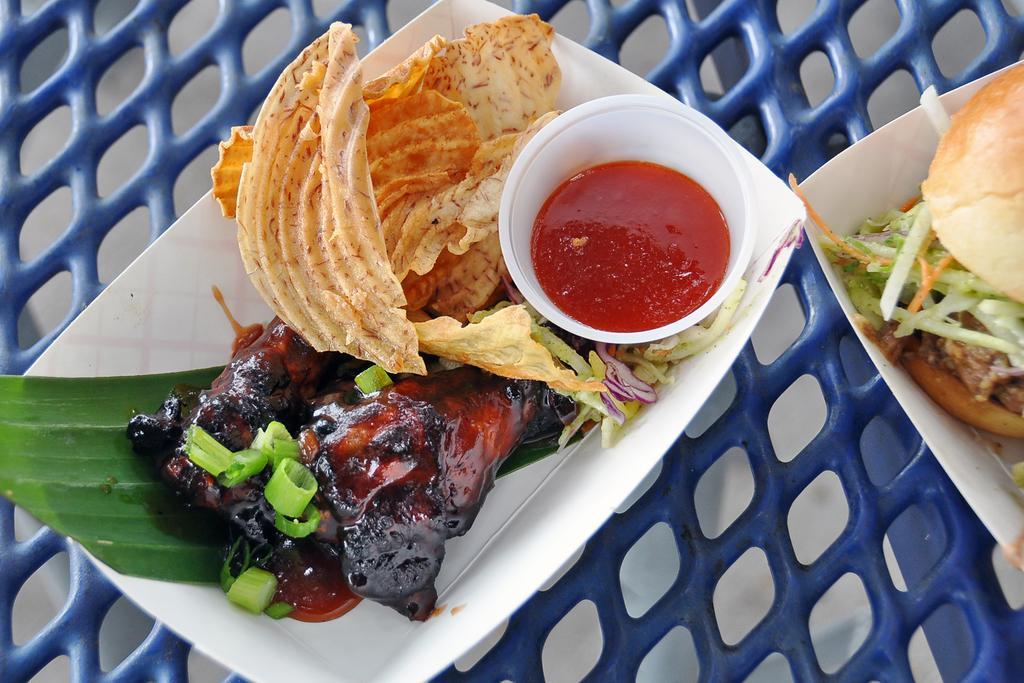Describe this image in one or two sentences. In this picture I can see 2 white color plates in front and on the plates I can see food which is of cream, black, red and few pieces of vegetables and on the left plate I can see a cup, in which I see the red color thing and I see that these 2 plates are on the blue color thing. 